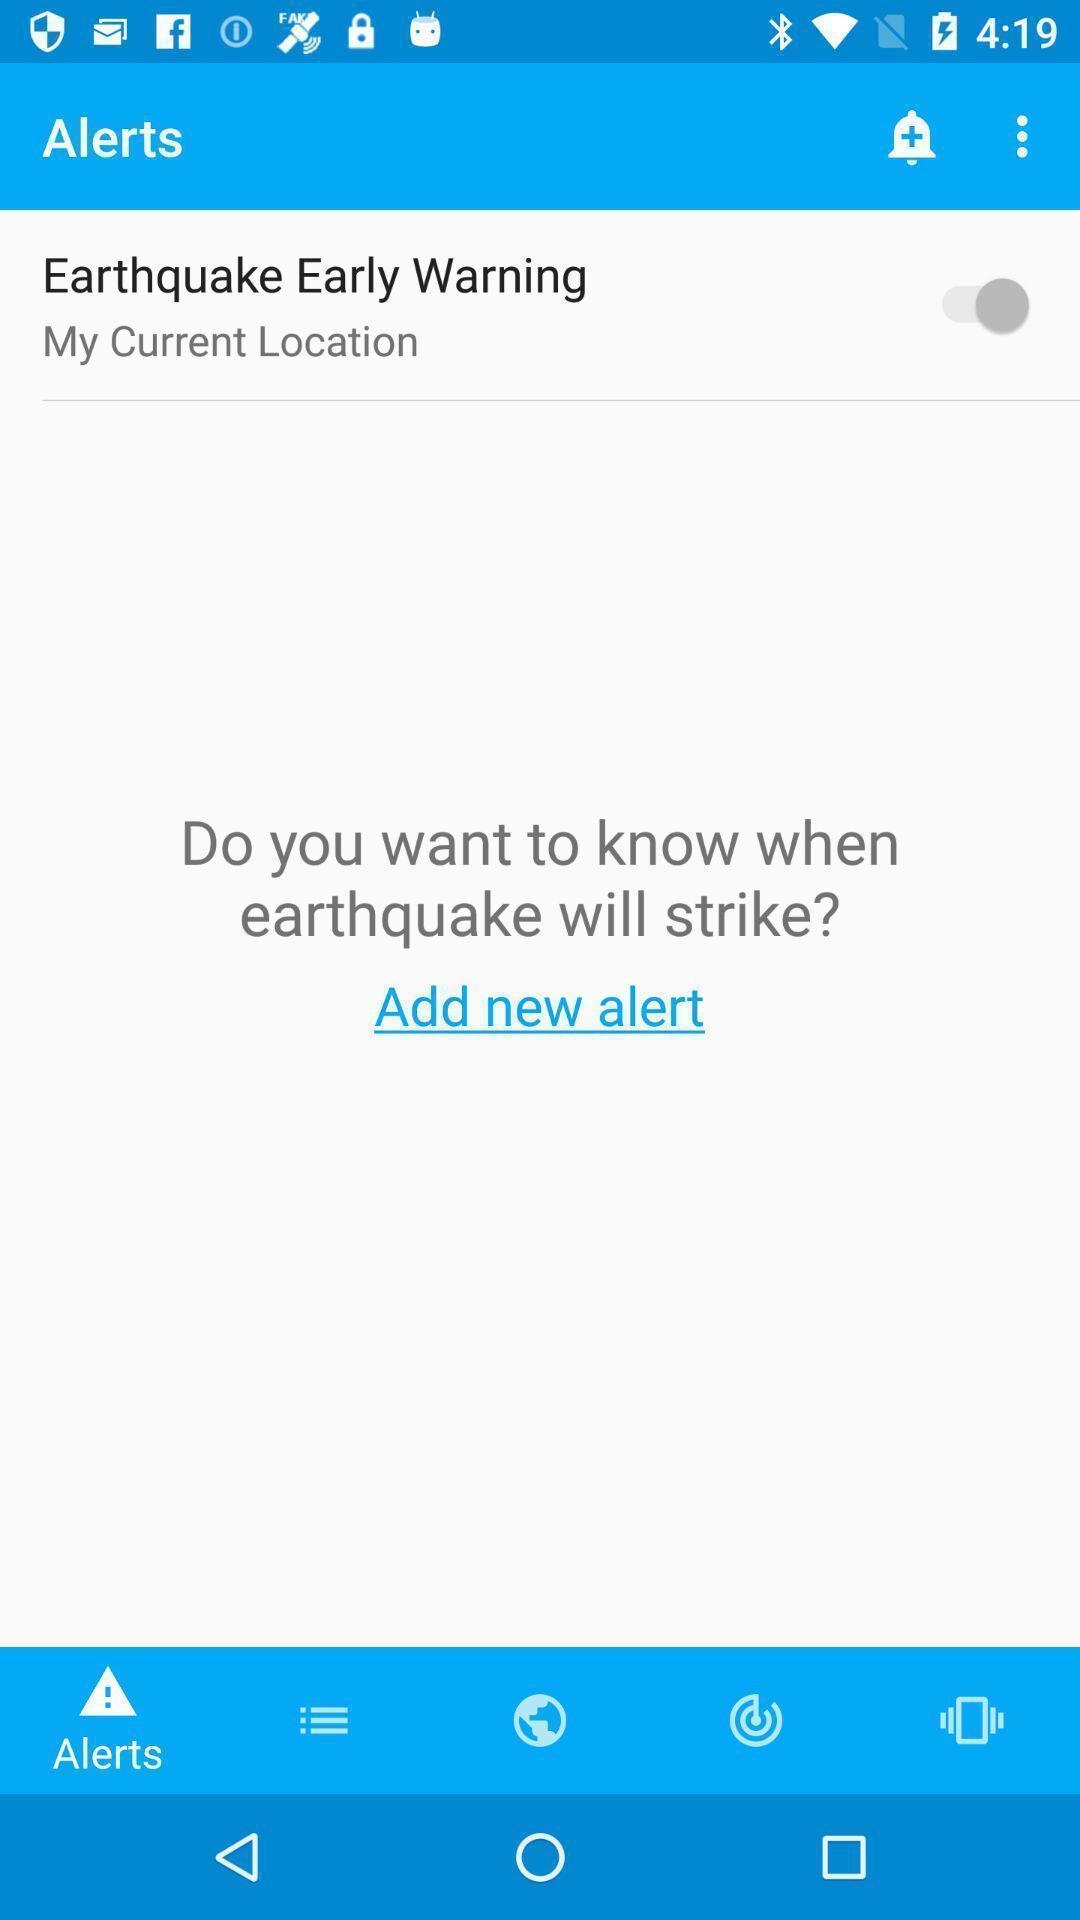What can you discern from this picture? Settings page of earthquake detection app. 